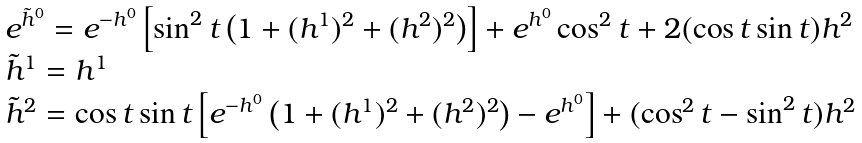<formula> <loc_0><loc_0><loc_500><loc_500>\begin{array} { l } { { e ^ { \tilde { h } ^ { 0 } } = e ^ { - h ^ { 0 } } \left [ \sin ^ { 2 } t \left ( 1 + ( h ^ { 1 } ) ^ { 2 } + ( h ^ { 2 } ) ^ { 2 } \right ) \right ] + e ^ { h ^ { 0 } } \cos ^ { 2 } t + 2 ( \cos t \sin t ) h ^ { 2 } } } \\ { { \tilde { h } ^ { 1 } = h ^ { 1 } } } \\ { { \tilde { h } ^ { 2 } = \cos t \sin t \left [ e ^ { - h ^ { 0 } } \left ( 1 + ( h ^ { 1 } ) ^ { 2 } + ( h ^ { 2 } ) ^ { 2 } \right ) - e ^ { h ^ { 0 } } \right ] + ( \cos ^ { 2 } t - \sin ^ { 2 } t ) h ^ { 2 } } } \end{array}</formula> 